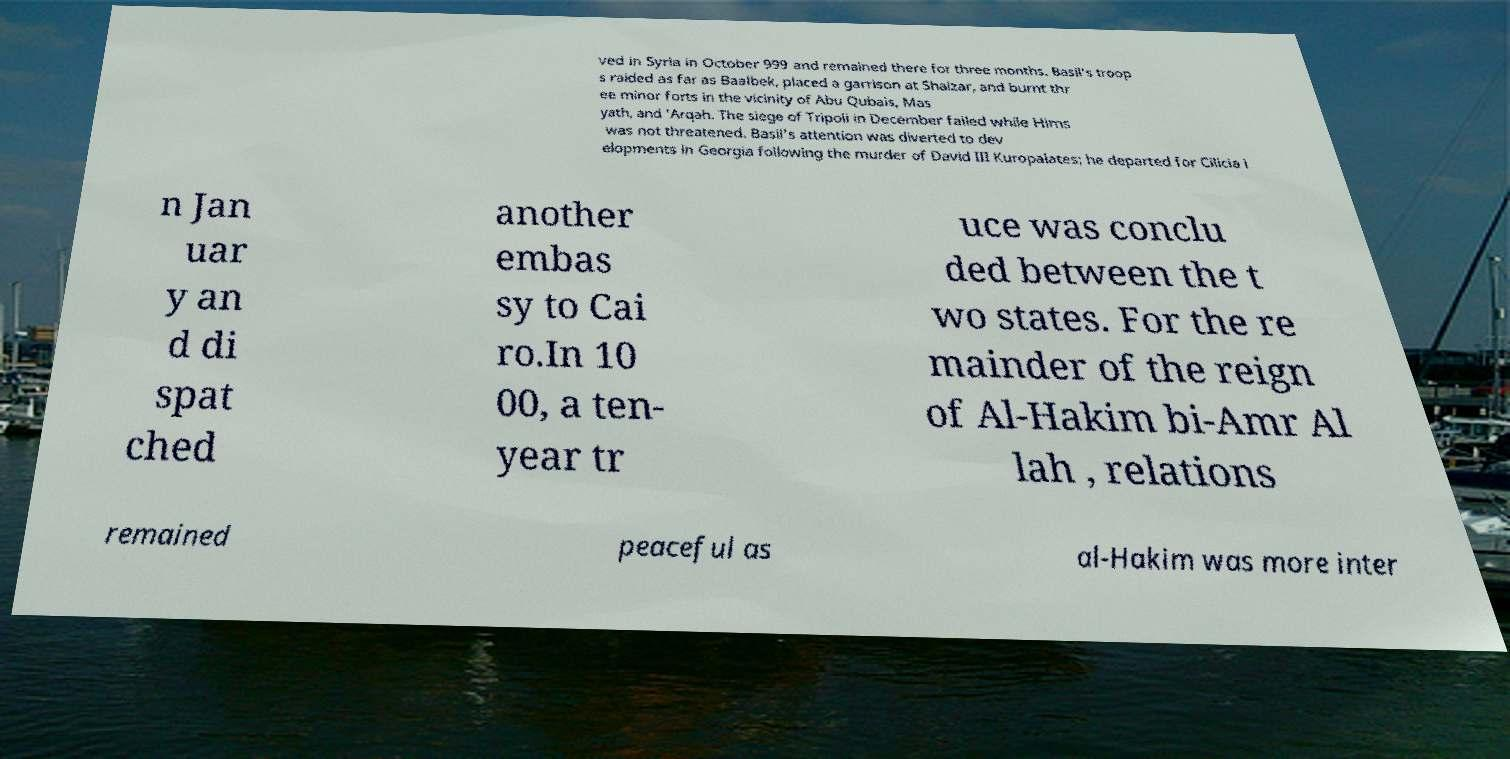Can you accurately transcribe the text from the provided image for me? ved in Syria in October 999 and remained there for three months. Basil's troop s raided as far as Baalbek, placed a garrison at Shaizar, and burnt thr ee minor forts in the vicinity of Abu Qubais, Mas yath, and 'Arqah. The siege of Tripoli in December failed while Hims was not threatened. Basil's attention was diverted to dev elopments in Georgia following the murder of David III Kuropalates; he departed for Cilicia i n Jan uar y an d di spat ched another embas sy to Cai ro.In 10 00, a ten- year tr uce was conclu ded between the t wo states. For the re mainder of the reign of Al-Hakim bi-Amr Al lah , relations remained peaceful as al-Hakim was more inter 